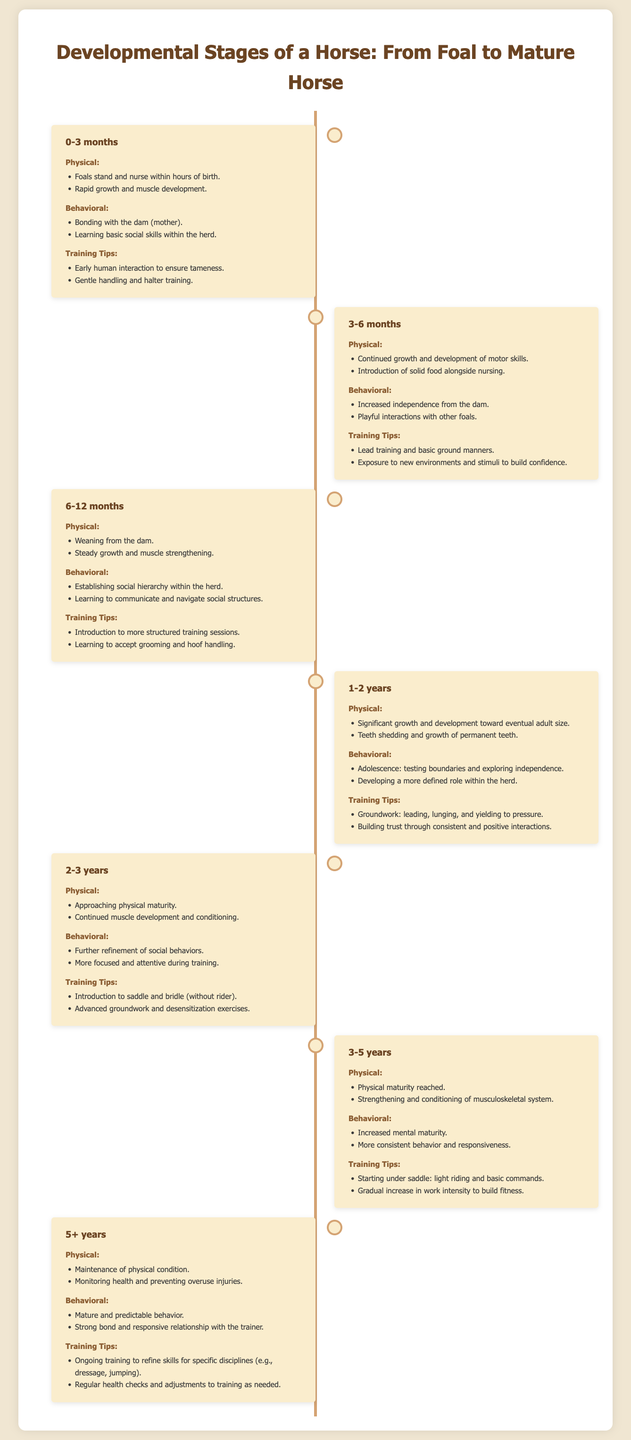what is the age range of a foal? The document specifies the age range of a foal as 0-3 months.
Answer: 0-3 months at what age does a horse reach physical maturity? The document states that physical maturity is reached at the age of 3-5 years.
Answer: 3-5 years what is a key behavioral milestone for a horse at 1-2 years? The behavioral milestone mentioned for a horse at 1-2 years is testing boundaries and exploring independence.
Answer: testing boundaries what type of training tips are suggested for a horse aged 2-3 years? The training tips include introducing the saddle and bridle (without rider) and advanced groundwork.
Answer: saddle and bridle how does the document categorize development at the age of 5+ years? The document categorizes development at 5+ years under physical, behavioral, and training tips.
Answer: physical, behavioral, training tips what is the primary focus of behavioral training for a 3-6 month old foal? The primary focus is on increased independence from the dam and playful interactions with other foals.
Answer: increased independence how should training sessions change for a horse aged 6-12 months? Training sessions should introduce more structured training.
Answer: more structured training what is a milestone for physical development by 3-5 years? The milestone for physical development mentioned is strengthening and conditioning of the musculoskeletal system.
Answer: strengthening and conditioning 